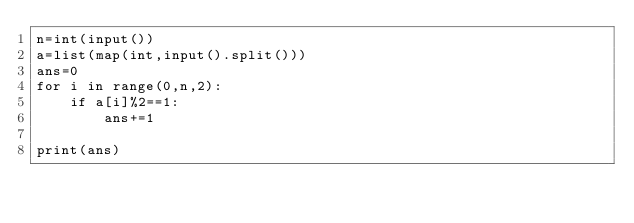<code> <loc_0><loc_0><loc_500><loc_500><_Python_>n=int(input())
a=list(map(int,input().split()))
ans=0
for i in range(0,n,2):
    if a[i]%2==1:
        ans+=1

print(ans)</code> 